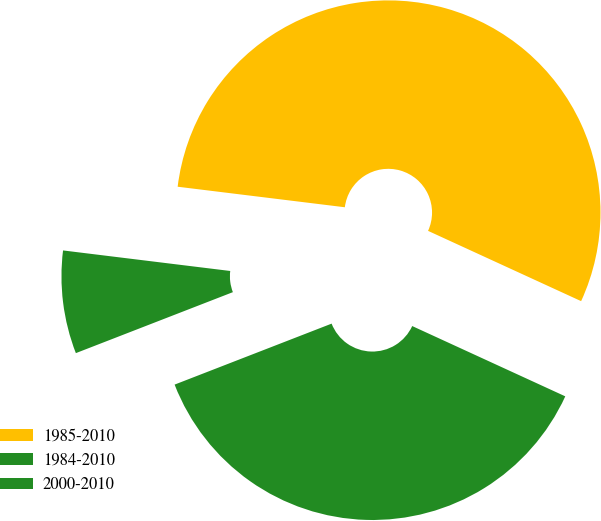Convert chart. <chart><loc_0><loc_0><loc_500><loc_500><pie_chart><fcel>1985-2010<fcel>1984-2010<fcel>2000-2010<nl><fcel>54.9%<fcel>7.84%<fcel>37.25%<nl></chart> 